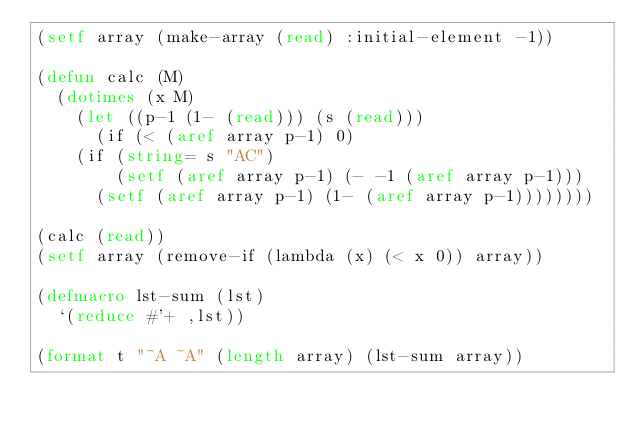<code> <loc_0><loc_0><loc_500><loc_500><_Lisp_>(setf array (make-array (read) :initial-element -1))

(defun calc (M)
  (dotimes (x M)
    (let ((p-1 (1- (read))) (s (read)))
      (if (< (aref array p-1) 0)
	  (if (string= s "AC")
	      (setf (aref array p-1) (- -1 (aref array p-1)))
	    (setf (aref array p-1) (1- (aref array p-1))))))))

(calc (read)) 
(setf array (remove-if (lambda (x) (< x 0)) array))

(defmacro lst-sum (lst)
  `(reduce #'+ ,lst))

(format t "~A ~A" (length array) (lst-sum array))</code> 